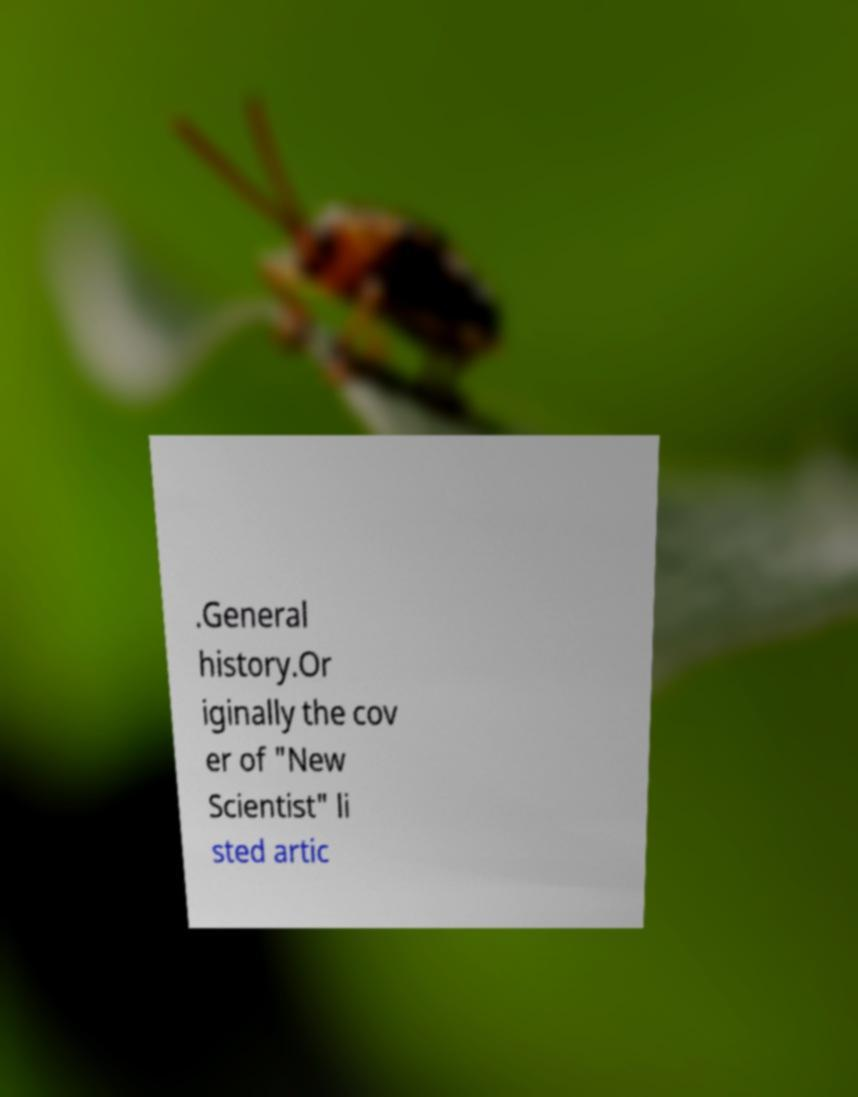Please identify and transcribe the text found in this image. .General history.Or iginally the cov er of "New Scientist" li sted artic 